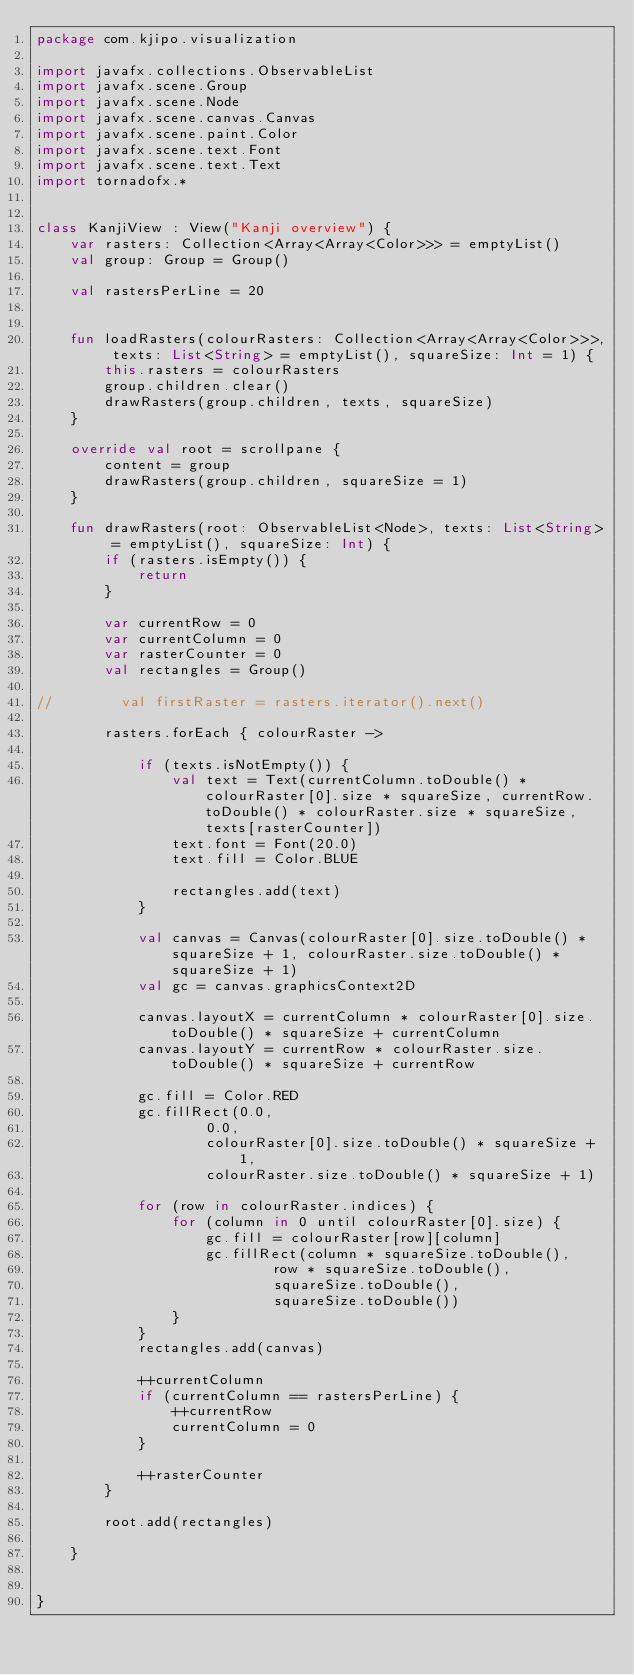Convert code to text. <code><loc_0><loc_0><loc_500><loc_500><_Kotlin_>package com.kjipo.visualization

import javafx.collections.ObservableList
import javafx.scene.Group
import javafx.scene.Node
import javafx.scene.canvas.Canvas
import javafx.scene.paint.Color
import javafx.scene.text.Font
import javafx.scene.text.Text
import tornadofx.*


class KanjiView : View("Kanji overview") {
    var rasters: Collection<Array<Array<Color>>> = emptyList()
    val group: Group = Group()

    val rastersPerLine = 20


    fun loadRasters(colourRasters: Collection<Array<Array<Color>>>, texts: List<String> = emptyList(), squareSize: Int = 1) {
        this.rasters = colourRasters
        group.children.clear()
        drawRasters(group.children, texts, squareSize)
    }

    override val root = scrollpane {
        content = group
        drawRasters(group.children, squareSize = 1)
    }

    fun drawRasters(root: ObservableList<Node>, texts: List<String> = emptyList(), squareSize: Int) {
        if (rasters.isEmpty()) {
            return
        }

        var currentRow = 0
        var currentColumn = 0
        var rasterCounter = 0
        val rectangles = Group()

//        val firstRaster = rasters.iterator().next()

        rasters.forEach { colourRaster ->

            if (texts.isNotEmpty()) {
                val text = Text(currentColumn.toDouble() * colourRaster[0].size * squareSize, currentRow.toDouble() * colourRaster.size * squareSize, texts[rasterCounter])
                text.font = Font(20.0)
                text.fill = Color.BLUE

                rectangles.add(text)
            }

            val canvas = Canvas(colourRaster[0].size.toDouble() * squareSize + 1, colourRaster.size.toDouble() * squareSize + 1)
            val gc = canvas.graphicsContext2D

            canvas.layoutX = currentColumn * colourRaster[0].size.toDouble() * squareSize + currentColumn
            canvas.layoutY = currentRow * colourRaster.size.toDouble() * squareSize + currentRow

            gc.fill = Color.RED
            gc.fillRect(0.0,
                    0.0,
                    colourRaster[0].size.toDouble() * squareSize + 1,
                    colourRaster.size.toDouble() * squareSize + 1)

            for (row in colourRaster.indices) {
                for (column in 0 until colourRaster[0].size) {
                    gc.fill = colourRaster[row][column]
                    gc.fillRect(column * squareSize.toDouble(),
                            row * squareSize.toDouble(),
                            squareSize.toDouble(),
                            squareSize.toDouble())
                }
            }
            rectangles.add(canvas)

            ++currentColumn
            if (currentColumn == rastersPerLine) {
                ++currentRow
                currentColumn = 0
            }

            ++rasterCounter
        }

        root.add(rectangles)

    }


}</code> 